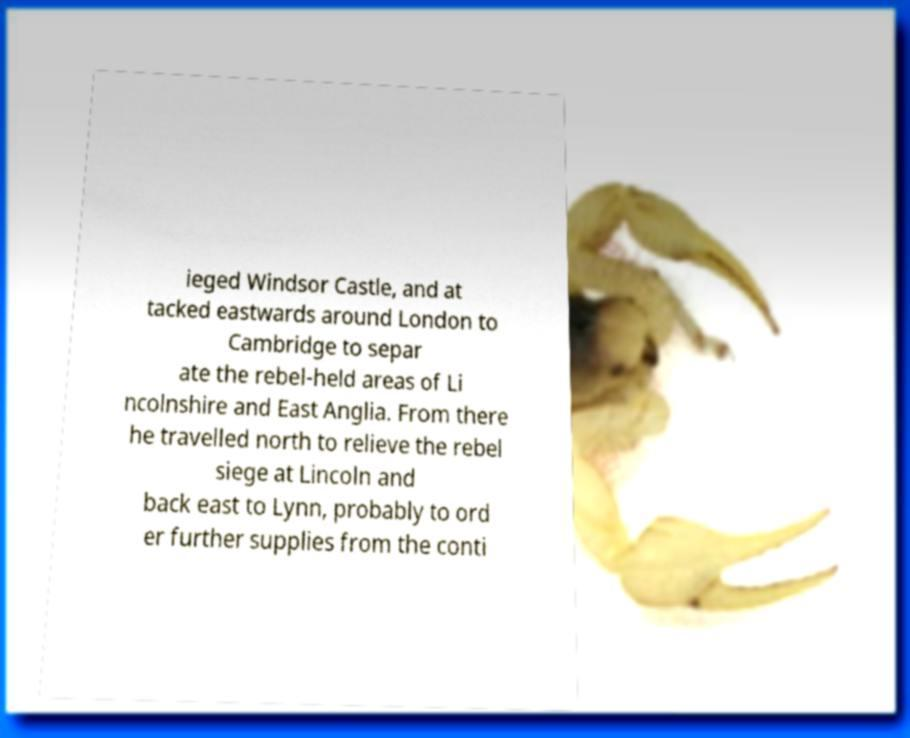There's text embedded in this image that I need extracted. Can you transcribe it verbatim? ieged Windsor Castle, and at tacked eastwards around London to Cambridge to separ ate the rebel-held areas of Li ncolnshire and East Anglia. From there he travelled north to relieve the rebel siege at Lincoln and back east to Lynn, probably to ord er further supplies from the conti 